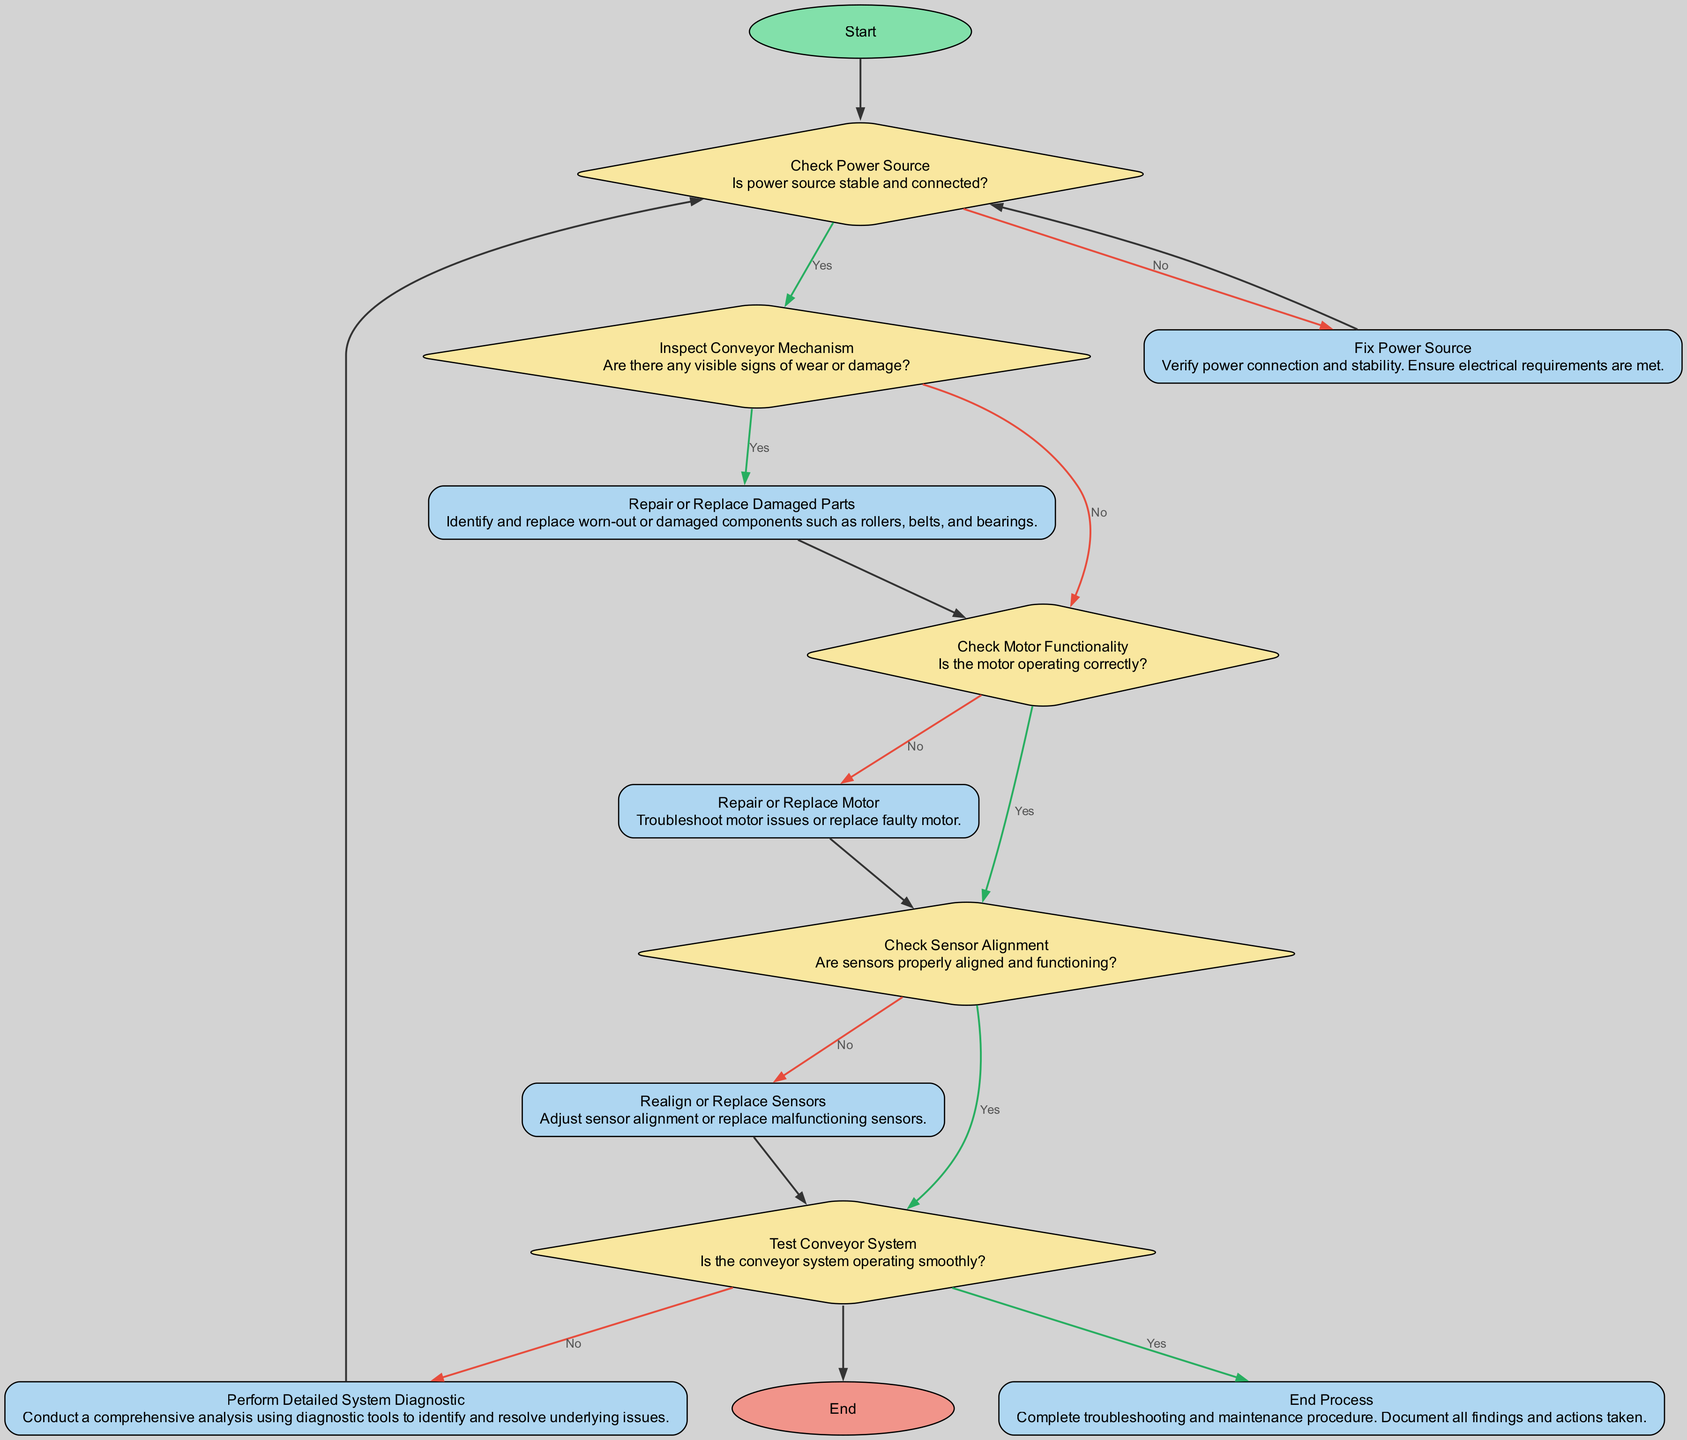What is the first action in the flow chart? The flow chart begins with the first action labeled "Initiate Inspection Process", which is the starting point of the troubleshooting process.
Answer: Initiate Inspection Process How many decision nodes are present in the diagram? By examining the diagram, you can count the decision nodes, which involve questions that lead to different paths in the flow. There are four decision nodes identified throughout the process.
Answer: 4 What action follows after "Fix Power Source"? Following the action "Fix Power Source," the next step to follow in the flow is to "Check Power Source" again to ensure the power has been stabilized.
Answer: Check Power Source If the motor is not operating correctly, what is the next action? If the motor is not functioning correctly, following the decision, the next step is to "Repair or Replace Motor," indicating that issues need to be addressed before proceeding.
Answer: Repair or Replace Motor What happens after the "Test Conveyor System" node if the system is not operating smoothly? If the "Test Conveyor System" indicates that the conveyor is not working smoothly, you would then "Perform Detailed System Diagnostic" to investigate and resolve underlying issues.
Answer: Perform Detailed System Diagnostic How does one proceed after identifying visible signs of wear or damage? Upon observing visible signs of wear or damage, the subsequent action is to "Repair or Replace Damaged Parts," thus addressing the identified problems.
Answer: Repair or Replace Damaged Parts What action concludes the troubleshooting and maintenance process? The process ends with the action labeled "Complete troubleshooting and maintenance procedure. Document all findings and actions taken," serving as the final step in the flow chart.
Answer: End Process What actions are included in the “Check Sensor Alignment” decision? The “Check Sensor Alignment” decision node leads to two outcomes based on whether the sensors are properly aligned or functioning: if yes, the next step is "Test Conveyor System," and if no, it directs to "Realign or Replace Sensors."
Answer: Test Conveyor System / Realign or Replace Sensors 